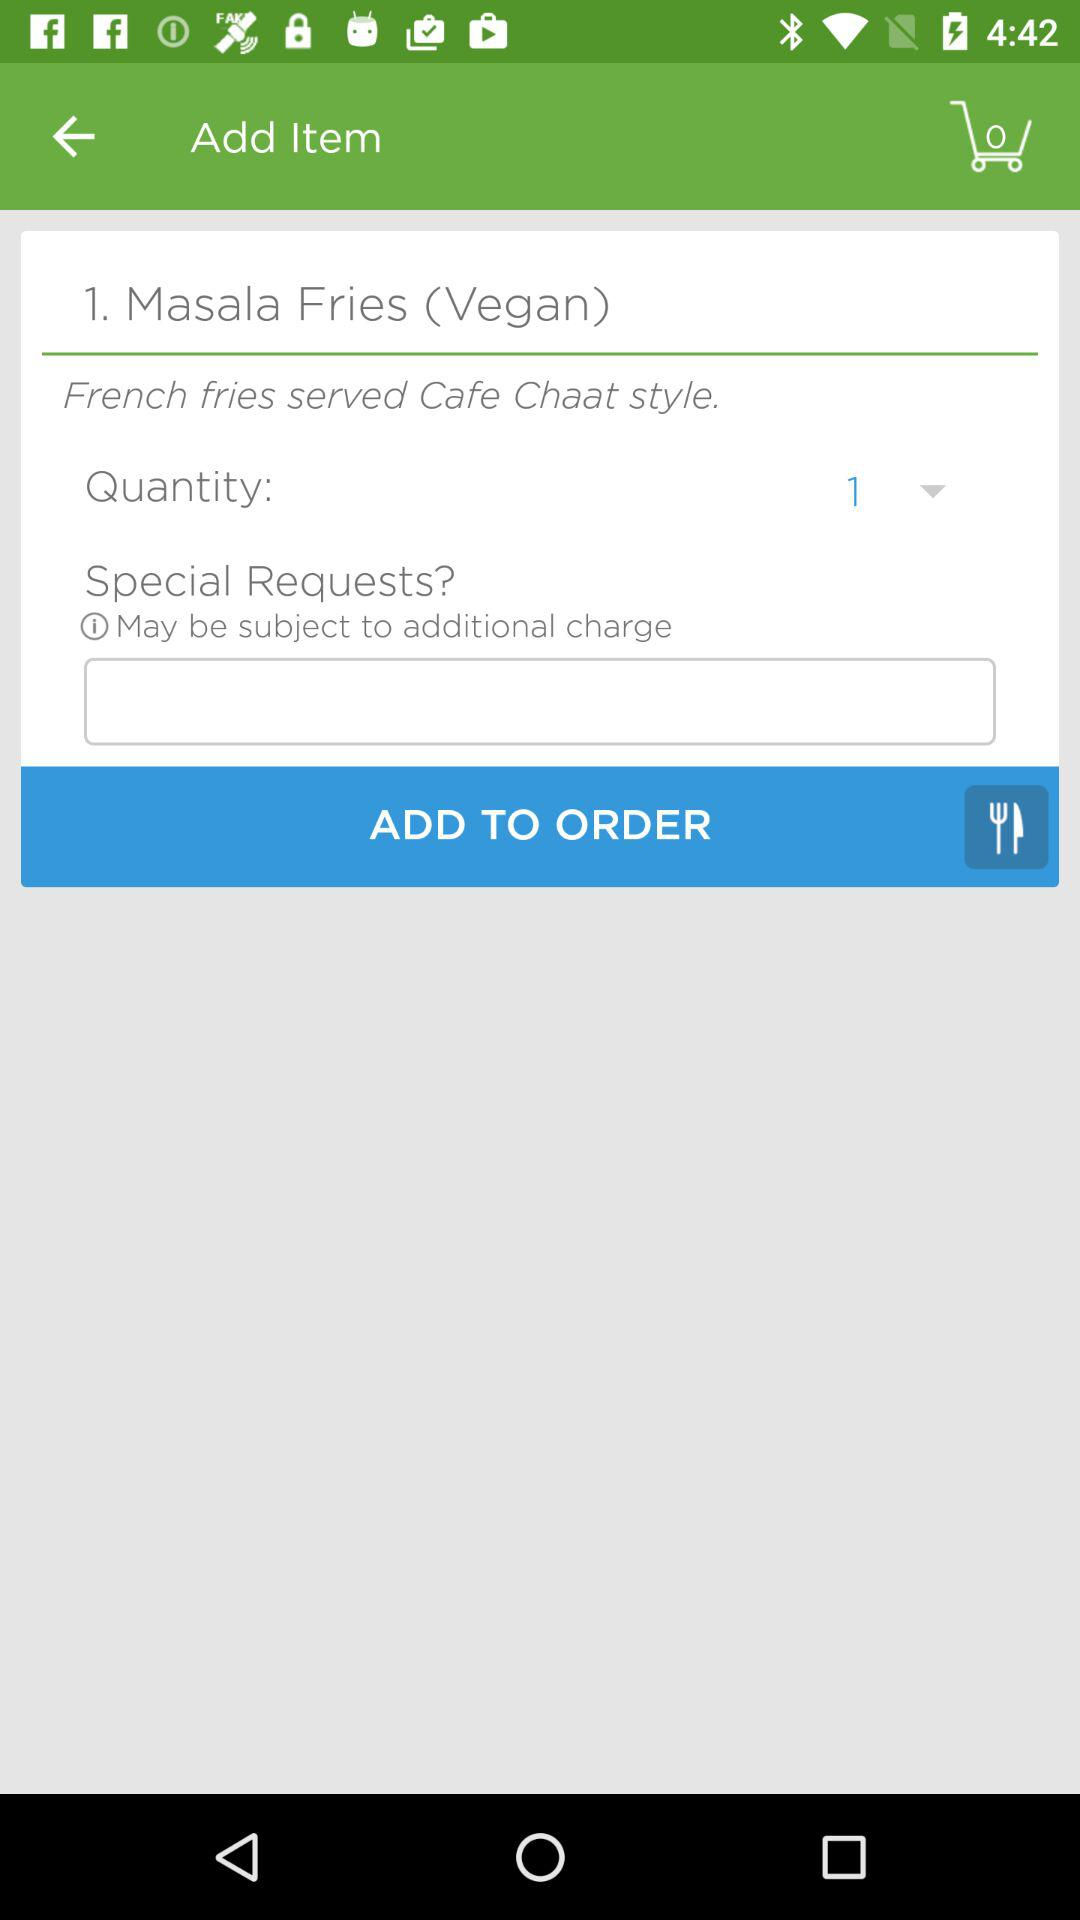How many items are in the cart? There are 0 items in the cart. 